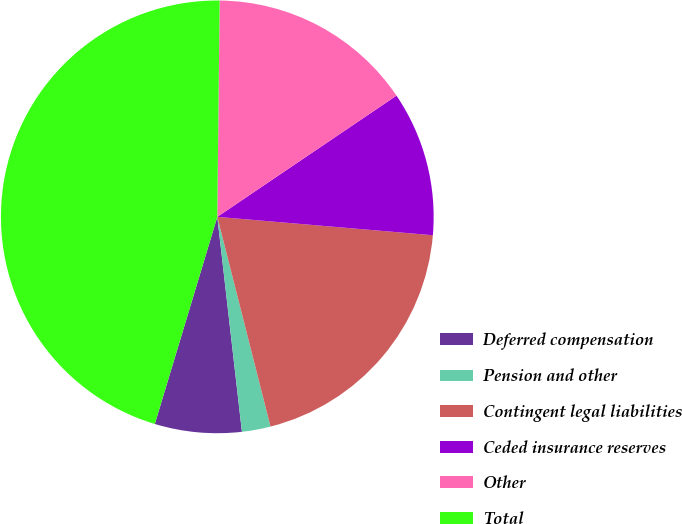Convert chart to OTSL. <chart><loc_0><loc_0><loc_500><loc_500><pie_chart><fcel>Deferred compensation<fcel>Pension and other<fcel>Contingent legal liabilities<fcel>Ceded insurance reserves<fcel>Other<fcel>Total<nl><fcel>6.48%<fcel>2.14%<fcel>19.69%<fcel>10.82%<fcel>15.36%<fcel>45.51%<nl></chart> 